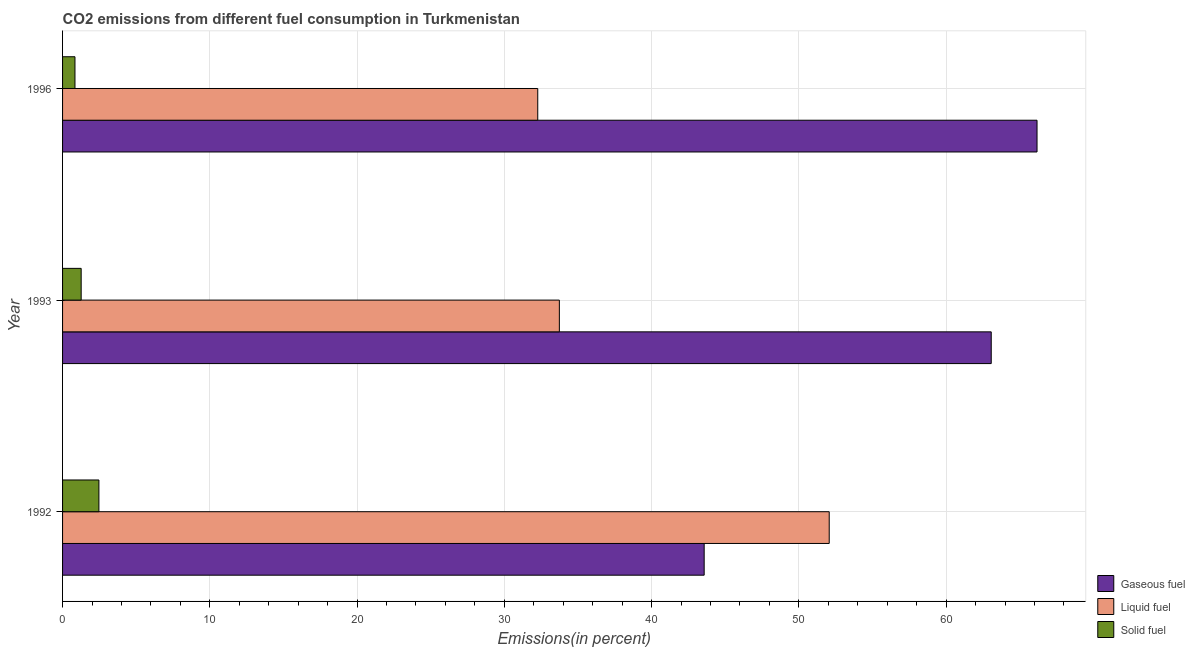How many different coloured bars are there?
Keep it short and to the point. 3. Are the number of bars per tick equal to the number of legend labels?
Offer a very short reply. Yes. How many bars are there on the 3rd tick from the top?
Offer a very short reply. 3. How many bars are there on the 2nd tick from the bottom?
Make the answer very short. 3. What is the percentage of solid fuel emission in 1993?
Ensure brevity in your answer.  1.26. Across all years, what is the maximum percentage of solid fuel emission?
Provide a short and direct response. 2.47. Across all years, what is the minimum percentage of liquid fuel emission?
Ensure brevity in your answer.  32.27. In which year was the percentage of gaseous fuel emission minimum?
Provide a short and direct response. 1992. What is the total percentage of liquid fuel emission in the graph?
Ensure brevity in your answer.  118.07. What is the difference between the percentage of solid fuel emission in 1992 and that in 1993?
Keep it short and to the point. 1.2. What is the difference between the percentage of gaseous fuel emission in 1996 and the percentage of solid fuel emission in 1993?
Your response must be concise. 64.91. What is the average percentage of solid fuel emission per year?
Make the answer very short. 1.52. In the year 1992, what is the difference between the percentage of liquid fuel emission and percentage of gaseous fuel emission?
Provide a short and direct response. 8.49. In how many years, is the percentage of liquid fuel emission greater than 44 %?
Provide a succinct answer. 1. What is the ratio of the percentage of gaseous fuel emission in 1992 to that in 1996?
Your answer should be very brief. 0.66. What is the difference between the highest and the second highest percentage of gaseous fuel emission?
Offer a very short reply. 3.11. What is the difference between the highest and the lowest percentage of liquid fuel emission?
Keep it short and to the point. 19.79. Is the sum of the percentage of gaseous fuel emission in 1993 and 1996 greater than the maximum percentage of liquid fuel emission across all years?
Make the answer very short. Yes. What does the 1st bar from the top in 1993 represents?
Offer a very short reply. Solid fuel. What does the 2nd bar from the bottom in 1996 represents?
Provide a succinct answer. Liquid fuel. Is it the case that in every year, the sum of the percentage of gaseous fuel emission and percentage of liquid fuel emission is greater than the percentage of solid fuel emission?
Provide a short and direct response. Yes. How many bars are there?
Offer a terse response. 9. Are all the bars in the graph horizontal?
Offer a very short reply. Yes. How many years are there in the graph?
Your response must be concise. 3. What is the difference between two consecutive major ticks on the X-axis?
Give a very brief answer. 10. Does the graph contain grids?
Ensure brevity in your answer.  Yes. Where does the legend appear in the graph?
Provide a succinct answer. Bottom right. How are the legend labels stacked?
Give a very brief answer. Vertical. What is the title of the graph?
Provide a succinct answer. CO2 emissions from different fuel consumption in Turkmenistan. What is the label or title of the X-axis?
Ensure brevity in your answer.  Emissions(in percent). What is the Emissions(in percent) of Gaseous fuel in 1992?
Give a very brief answer. 43.57. What is the Emissions(in percent) of Liquid fuel in 1992?
Give a very brief answer. 52.06. What is the Emissions(in percent) of Solid fuel in 1992?
Offer a terse response. 2.47. What is the Emissions(in percent) in Gaseous fuel in 1993?
Your response must be concise. 63.07. What is the Emissions(in percent) in Liquid fuel in 1993?
Your answer should be very brief. 33.74. What is the Emissions(in percent) in Solid fuel in 1993?
Keep it short and to the point. 1.26. What is the Emissions(in percent) of Gaseous fuel in 1996?
Your response must be concise. 66.18. What is the Emissions(in percent) of Liquid fuel in 1996?
Give a very brief answer. 32.27. What is the Emissions(in percent) of Solid fuel in 1996?
Your response must be concise. 0.84. Across all years, what is the maximum Emissions(in percent) of Gaseous fuel?
Ensure brevity in your answer.  66.18. Across all years, what is the maximum Emissions(in percent) in Liquid fuel?
Keep it short and to the point. 52.06. Across all years, what is the maximum Emissions(in percent) in Solid fuel?
Give a very brief answer. 2.47. Across all years, what is the minimum Emissions(in percent) in Gaseous fuel?
Provide a short and direct response. 43.57. Across all years, what is the minimum Emissions(in percent) in Liquid fuel?
Your answer should be compact. 32.27. Across all years, what is the minimum Emissions(in percent) in Solid fuel?
Offer a very short reply. 0.84. What is the total Emissions(in percent) of Gaseous fuel in the graph?
Offer a terse response. 172.81. What is the total Emissions(in percent) of Liquid fuel in the graph?
Your answer should be very brief. 118.07. What is the total Emissions(in percent) in Solid fuel in the graph?
Make the answer very short. 4.57. What is the difference between the Emissions(in percent) in Gaseous fuel in 1992 and that in 1993?
Keep it short and to the point. -19.49. What is the difference between the Emissions(in percent) of Liquid fuel in 1992 and that in 1993?
Make the answer very short. 18.33. What is the difference between the Emissions(in percent) of Solid fuel in 1992 and that in 1993?
Offer a terse response. 1.2. What is the difference between the Emissions(in percent) in Gaseous fuel in 1992 and that in 1996?
Ensure brevity in your answer.  -22.6. What is the difference between the Emissions(in percent) of Liquid fuel in 1992 and that in 1996?
Your response must be concise. 19.79. What is the difference between the Emissions(in percent) in Solid fuel in 1992 and that in 1996?
Your answer should be compact. 1.63. What is the difference between the Emissions(in percent) of Gaseous fuel in 1993 and that in 1996?
Provide a succinct answer. -3.11. What is the difference between the Emissions(in percent) of Liquid fuel in 1993 and that in 1996?
Your answer should be compact. 1.47. What is the difference between the Emissions(in percent) in Solid fuel in 1993 and that in 1996?
Ensure brevity in your answer.  0.42. What is the difference between the Emissions(in percent) of Gaseous fuel in 1992 and the Emissions(in percent) of Liquid fuel in 1993?
Offer a terse response. 9.83. What is the difference between the Emissions(in percent) of Gaseous fuel in 1992 and the Emissions(in percent) of Solid fuel in 1993?
Your answer should be very brief. 42.31. What is the difference between the Emissions(in percent) in Liquid fuel in 1992 and the Emissions(in percent) in Solid fuel in 1993?
Make the answer very short. 50.8. What is the difference between the Emissions(in percent) of Gaseous fuel in 1992 and the Emissions(in percent) of Liquid fuel in 1996?
Your response must be concise. 11.3. What is the difference between the Emissions(in percent) of Gaseous fuel in 1992 and the Emissions(in percent) of Solid fuel in 1996?
Give a very brief answer. 42.73. What is the difference between the Emissions(in percent) of Liquid fuel in 1992 and the Emissions(in percent) of Solid fuel in 1996?
Give a very brief answer. 51.22. What is the difference between the Emissions(in percent) in Gaseous fuel in 1993 and the Emissions(in percent) in Liquid fuel in 1996?
Your response must be concise. 30.8. What is the difference between the Emissions(in percent) in Gaseous fuel in 1993 and the Emissions(in percent) in Solid fuel in 1996?
Give a very brief answer. 62.22. What is the difference between the Emissions(in percent) in Liquid fuel in 1993 and the Emissions(in percent) in Solid fuel in 1996?
Your answer should be compact. 32.9. What is the average Emissions(in percent) in Gaseous fuel per year?
Make the answer very short. 57.6. What is the average Emissions(in percent) of Liquid fuel per year?
Offer a terse response. 39.36. What is the average Emissions(in percent) in Solid fuel per year?
Offer a very short reply. 1.52. In the year 1992, what is the difference between the Emissions(in percent) of Gaseous fuel and Emissions(in percent) of Liquid fuel?
Offer a very short reply. -8.49. In the year 1992, what is the difference between the Emissions(in percent) in Gaseous fuel and Emissions(in percent) in Solid fuel?
Ensure brevity in your answer.  41.1. In the year 1992, what is the difference between the Emissions(in percent) in Liquid fuel and Emissions(in percent) in Solid fuel?
Provide a short and direct response. 49.59. In the year 1993, what is the difference between the Emissions(in percent) in Gaseous fuel and Emissions(in percent) in Liquid fuel?
Ensure brevity in your answer.  29.33. In the year 1993, what is the difference between the Emissions(in percent) of Gaseous fuel and Emissions(in percent) of Solid fuel?
Provide a short and direct response. 61.8. In the year 1993, what is the difference between the Emissions(in percent) in Liquid fuel and Emissions(in percent) in Solid fuel?
Provide a short and direct response. 32.47. In the year 1996, what is the difference between the Emissions(in percent) in Gaseous fuel and Emissions(in percent) in Liquid fuel?
Give a very brief answer. 33.91. In the year 1996, what is the difference between the Emissions(in percent) of Gaseous fuel and Emissions(in percent) of Solid fuel?
Make the answer very short. 65.33. In the year 1996, what is the difference between the Emissions(in percent) in Liquid fuel and Emissions(in percent) in Solid fuel?
Provide a short and direct response. 31.43. What is the ratio of the Emissions(in percent) in Gaseous fuel in 1992 to that in 1993?
Provide a succinct answer. 0.69. What is the ratio of the Emissions(in percent) of Liquid fuel in 1992 to that in 1993?
Make the answer very short. 1.54. What is the ratio of the Emissions(in percent) of Solid fuel in 1992 to that in 1993?
Provide a succinct answer. 1.95. What is the ratio of the Emissions(in percent) in Gaseous fuel in 1992 to that in 1996?
Make the answer very short. 0.66. What is the ratio of the Emissions(in percent) of Liquid fuel in 1992 to that in 1996?
Offer a very short reply. 1.61. What is the ratio of the Emissions(in percent) of Solid fuel in 1992 to that in 1996?
Offer a very short reply. 2.93. What is the ratio of the Emissions(in percent) of Gaseous fuel in 1993 to that in 1996?
Keep it short and to the point. 0.95. What is the ratio of the Emissions(in percent) in Liquid fuel in 1993 to that in 1996?
Your answer should be compact. 1.05. What is the ratio of the Emissions(in percent) in Solid fuel in 1993 to that in 1996?
Offer a terse response. 1.5. What is the difference between the highest and the second highest Emissions(in percent) of Gaseous fuel?
Offer a terse response. 3.11. What is the difference between the highest and the second highest Emissions(in percent) in Liquid fuel?
Provide a succinct answer. 18.33. What is the difference between the highest and the second highest Emissions(in percent) in Solid fuel?
Offer a terse response. 1.2. What is the difference between the highest and the lowest Emissions(in percent) of Gaseous fuel?
Your response must be concise. 22.6. What is the difference between the highest and the lowest Emissions(in percent) in Liquid fuel?
Give a very brief answer. 19.79. What is the difference between the highest and the lowest Emissions(in percent) of Solid fuel?
Offer a very short reply. 1.63. 